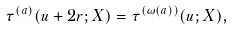<formula> <loc_0><loc_0><loc_500><loc_500>\tau ^ { ( a ) } ( u + 2 r ; X ) = \tau ^ { ( \omega ( a ) ) } ( u ; X ) ,</formula> 